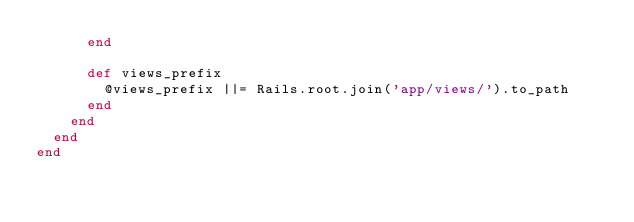<code> <loc_0><loc_0><loc_500><loc_500><_Ruby_>      end

      def views_prefix
        @views_prefix ||= Rails.root.join('app/views/').to_path
      end
    end
  end
end
</code> 